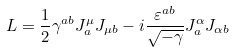Convert formula to latex. <formula><loc_0><loc_0><loc_500><loc_500>L = \frac { 1 } { 2 } \gamma ^ { a b } J ^ { \mu } _ { a } J _ { \mu b } - i \frac { \varepsilon ^ { a b } } { \sqrt { - \gamma } } J ^ { \alpha } _ { a } J _ { \alpha b }</formula> 